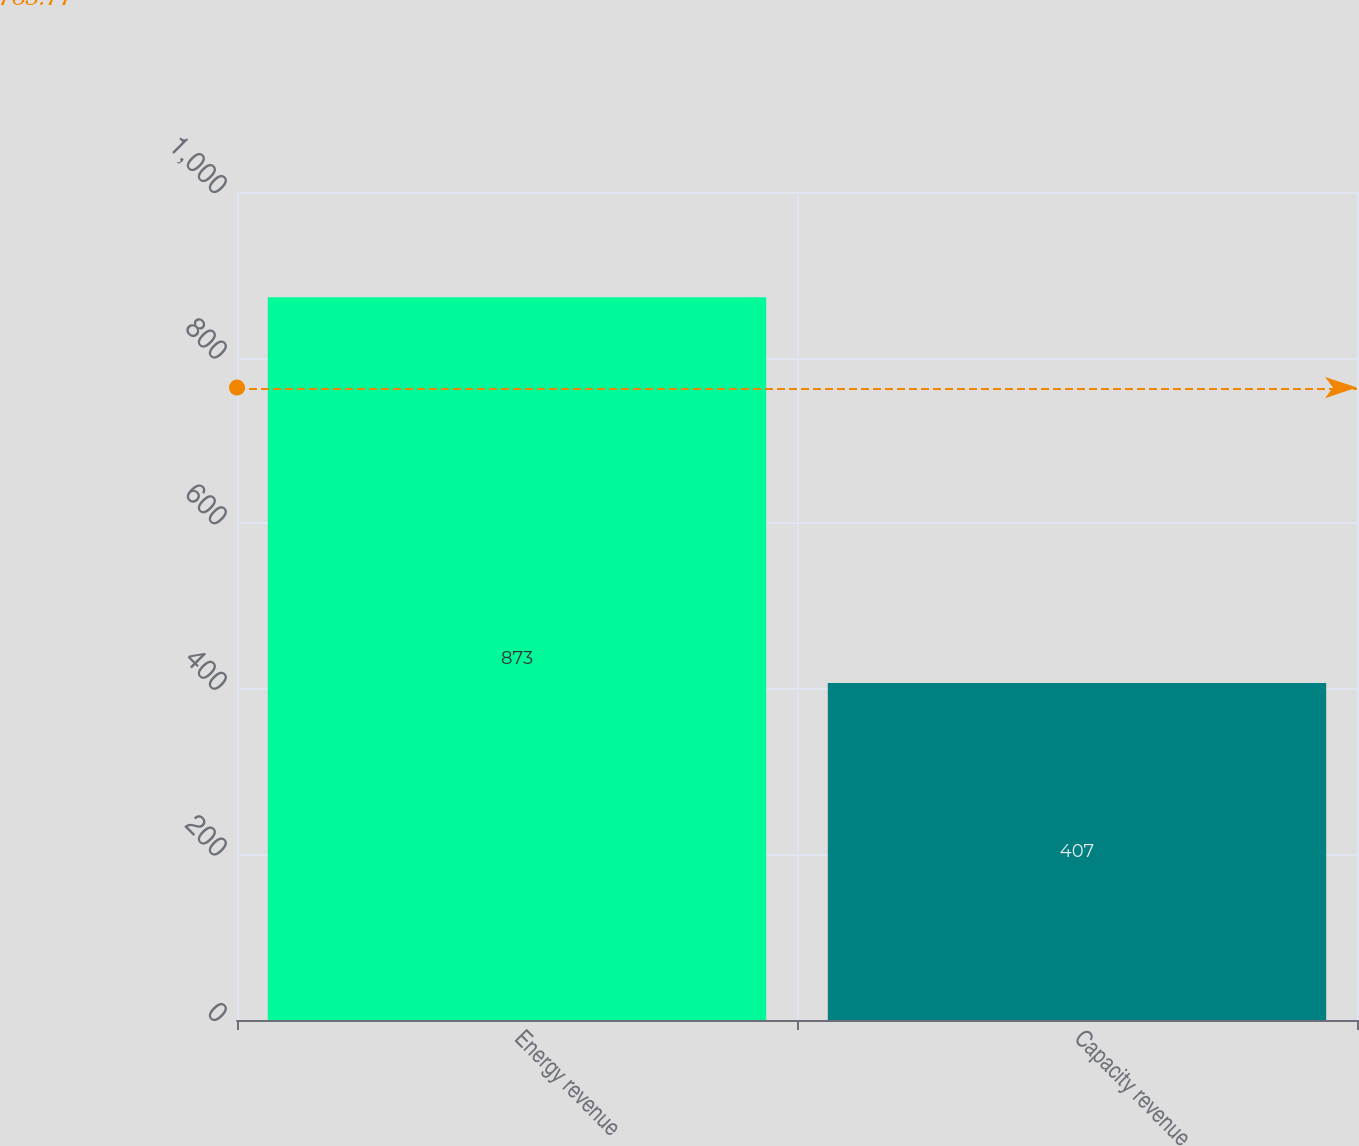<chart> <loc_0><loc_0><loc_500><loc_500><bar_chart><fcel>Energy revenue<fcel>Capacity revenue<nl><fcel>873<fcel>407<nl></chart> 